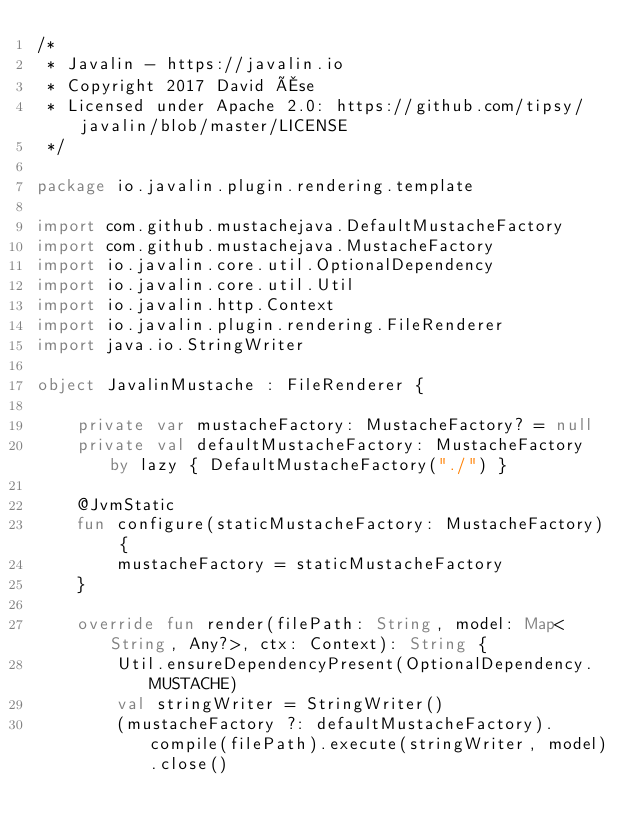<code> <loc_0><loc_0><loc_500><loc_500><_Kotlin_>/*
 * Javalin - https://javalin.io
 * Copyright 2017 David Åse
 * Licensed under Apache 2.0: https://github.com/tipsy/javalin/blob/master/LICENSE
 */

package io.javalin.plugin.rendering.template

import com.github.mustachejava.DefaultMustacheFactory
import com.github.mustachejava.MustacheFactory
import io.javalin.core.util.OptionalDependency
import io.javalin.core.util.Util
import io.javalin.http.Context
import io.javalin.plugin.rendering.FileRenderer
import java.io.StringWriter

object JavalinMustache : FileRenderer {

    private var mustacheFactory: MustacheFactory? = null
    private val defaultMustacheFactory: MustacheFactory by lazy { DefaultMustacheFactory("./") }

    @JvmStatic
    fun configure(staticMustacheFactory: MustacheFactory) {
        mustacheFactory = staticMustacheFactory
    }

    override fun render(filePath: String, model: Map<String, Any?>, ctx: Context): String {
        Util.ensureDependencyPresent(OptionalDependency.MUSTACHE)
        val stringWriter = StringWriter()
        (mustacheFactory ?: defaultMustacheFactory).compile(filePath).execute(stringWriter, model).close()</code> 